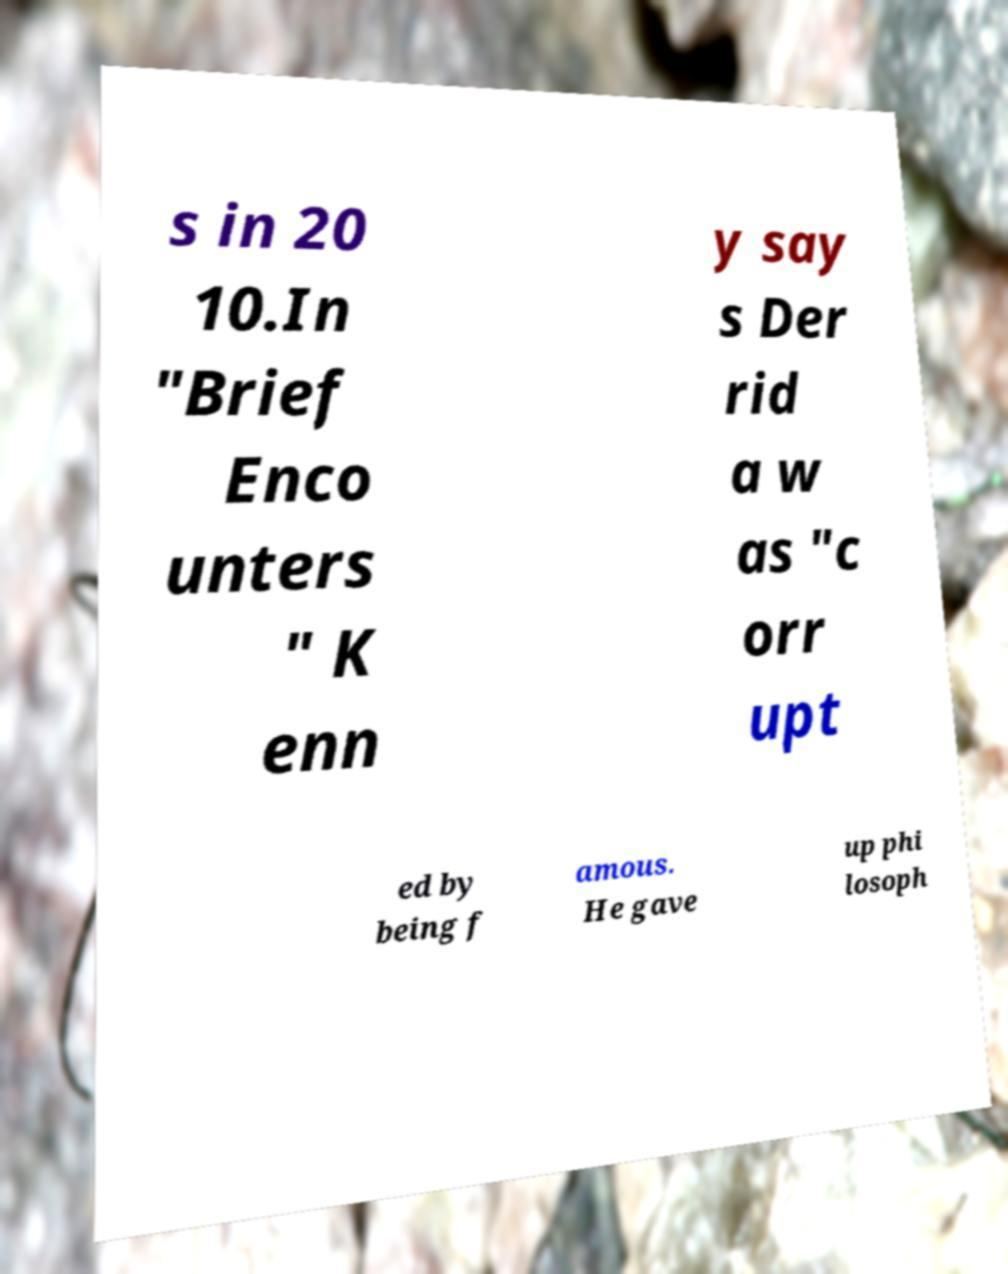There's text embedded in this image that I need extracted. Can you transcribe it verbatim? s in 20 10.In "Brief Enco unters " K enn y say s Der rid a w as "c orr upt ed by being f amous. He gave up phi losoph 